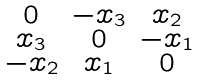Convert formula to latex. <formula><loc_0><loc_0><loc_500><loc_500>\begin{smallmatrix} 0 & - x _ { 3 } & x _ { 2 } \\ x _ { 3 } & 0 & - x _ { 1 } \\ - x _ { 2 } & x _ { 1 } & 0 \end{smallmatrix}</formula> 